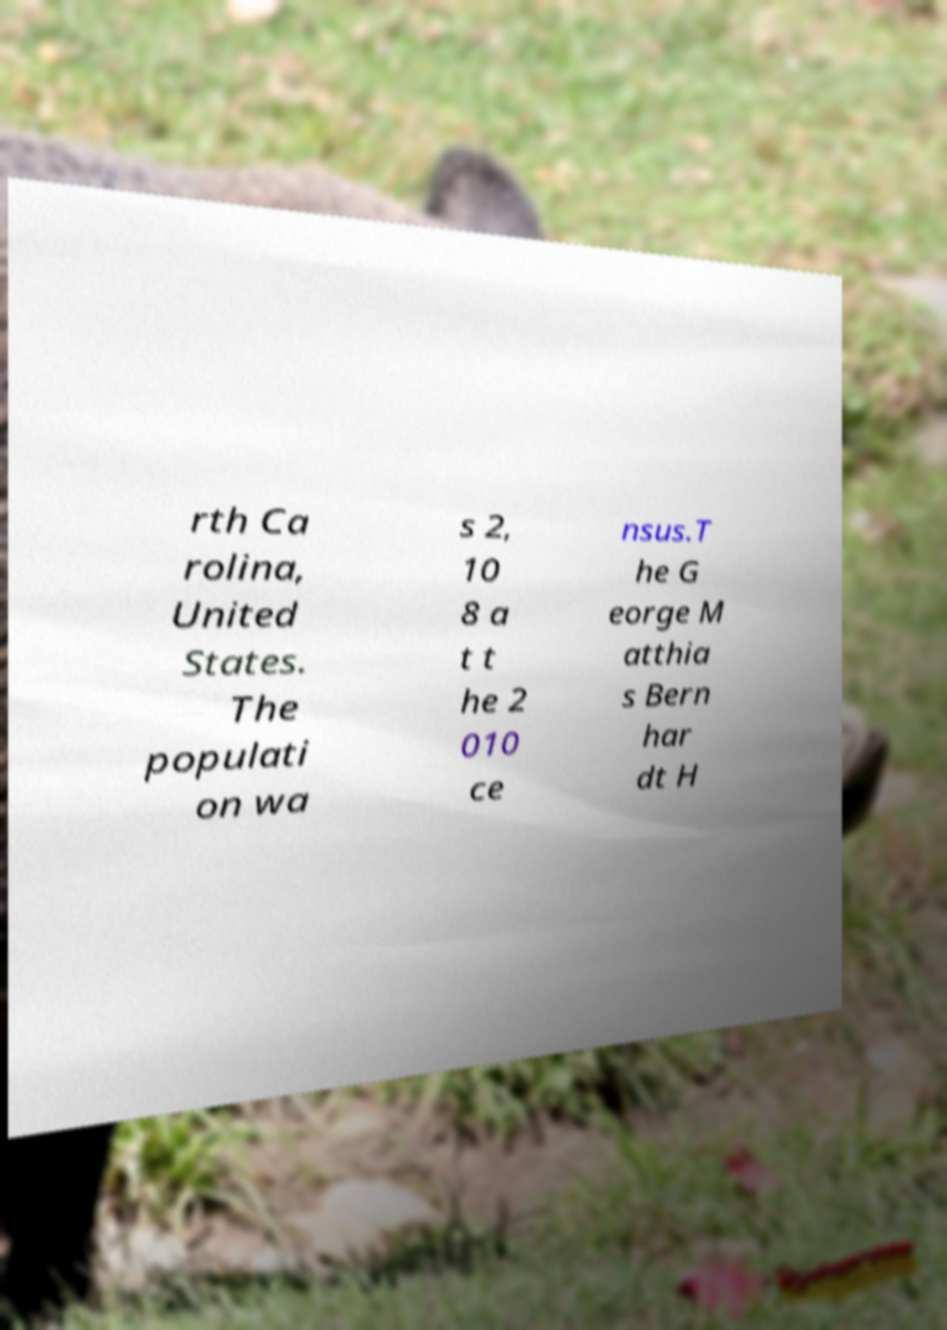Could you extract and type out the text from this image? rth Ca rolina, United States. The populati on wa s 2, 10 8 a t t he 2 010 ce nsus.T he G eorge M atthia s Bern har dt H 